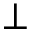Convert formula to latex. <formula><loc_0><loc_0><loc_500><loc_500>\perp</formula> 